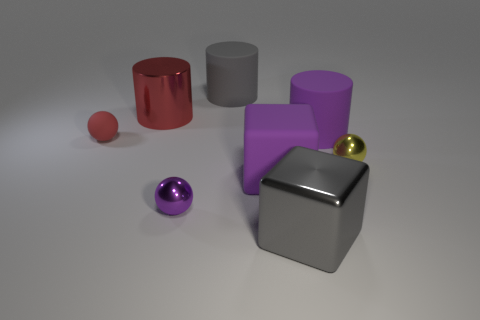Are there any rubber objects behind the purple rubber cylinder?
Your answer should be very brief. Yes. Are there any other small objects that have the same shape as the purple metallic object?
Provide a succinct answer. Yes. Is the shape of the purple object that is on the left side of the gray matte object the same as the rubber thing that is behind the metal cylinder?
Make the answer very short. No. Are there any other yellow spheres that have the same size as the matte sphere?
Make the answer very short. Yes. Are there an equal number of big purple cylinders to the right of the metal cylinder and tiny shiny balls on the left side of the large purple cylinder?
Offer a terse response. Yes. Is the gray thing that is in front of the rubber sphere made of the same material as the object on the left side of the large shiny cylinder?
Give a very brief answer. No. What is the large red thing made of?
Offer a terse response. Metal. What number of other things are the same color as the large rubber cube?
Make the answer very short. 2. Is the color of the large shiny cylinder the same as the tiny rubber object?
Offer a terse response. Yes. What number of small purple metallic things are there?
Provide a succinct answer. 1. 